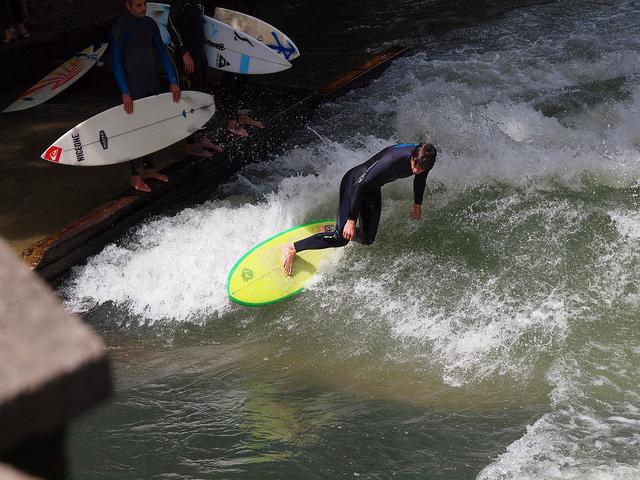Is the man barefoot?
Quick response, please. Yes. Are there waves?
Quick response, please. Yes. How many boards in the water?
Quick response, please. 1. Is this a man-made surfing area?
Concise answer only. Yes. How many surfboards are there?
Short answer required. 5. 